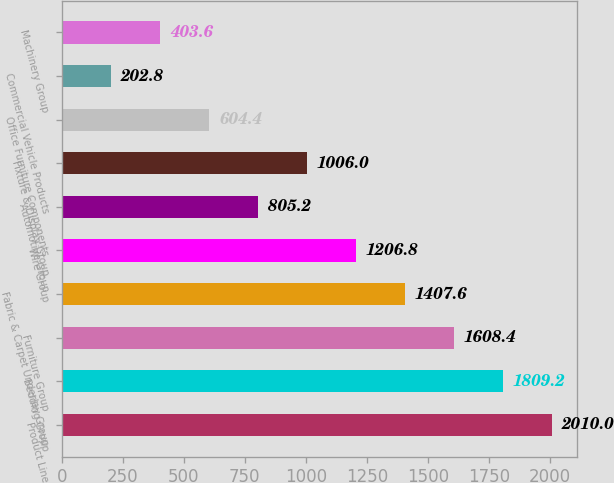Convert chart. <chart><loc_0><loc_0><loc_500><loc_500><bar_chart><fcel>Product Line<fcel>Bedding Group<fcel>Furniture Group<fcel>Fabric & Carpet Underlay Group<fcel>Wire Group<fcel>Automotive Group<fcel>Fixture & Display Group<fcel>Office Furniture Components<fcel>Commercial Vehicle Products<fcel>Machinery Group<nl><fcel>2010<fcel>1809.2<fcel>1608.4<fcel>1407.6<fcel>1206.8<fcel>805.2<fcel>1006<fcel>604.4<fcel>202.8<fcel>403.6<nl></chart> 